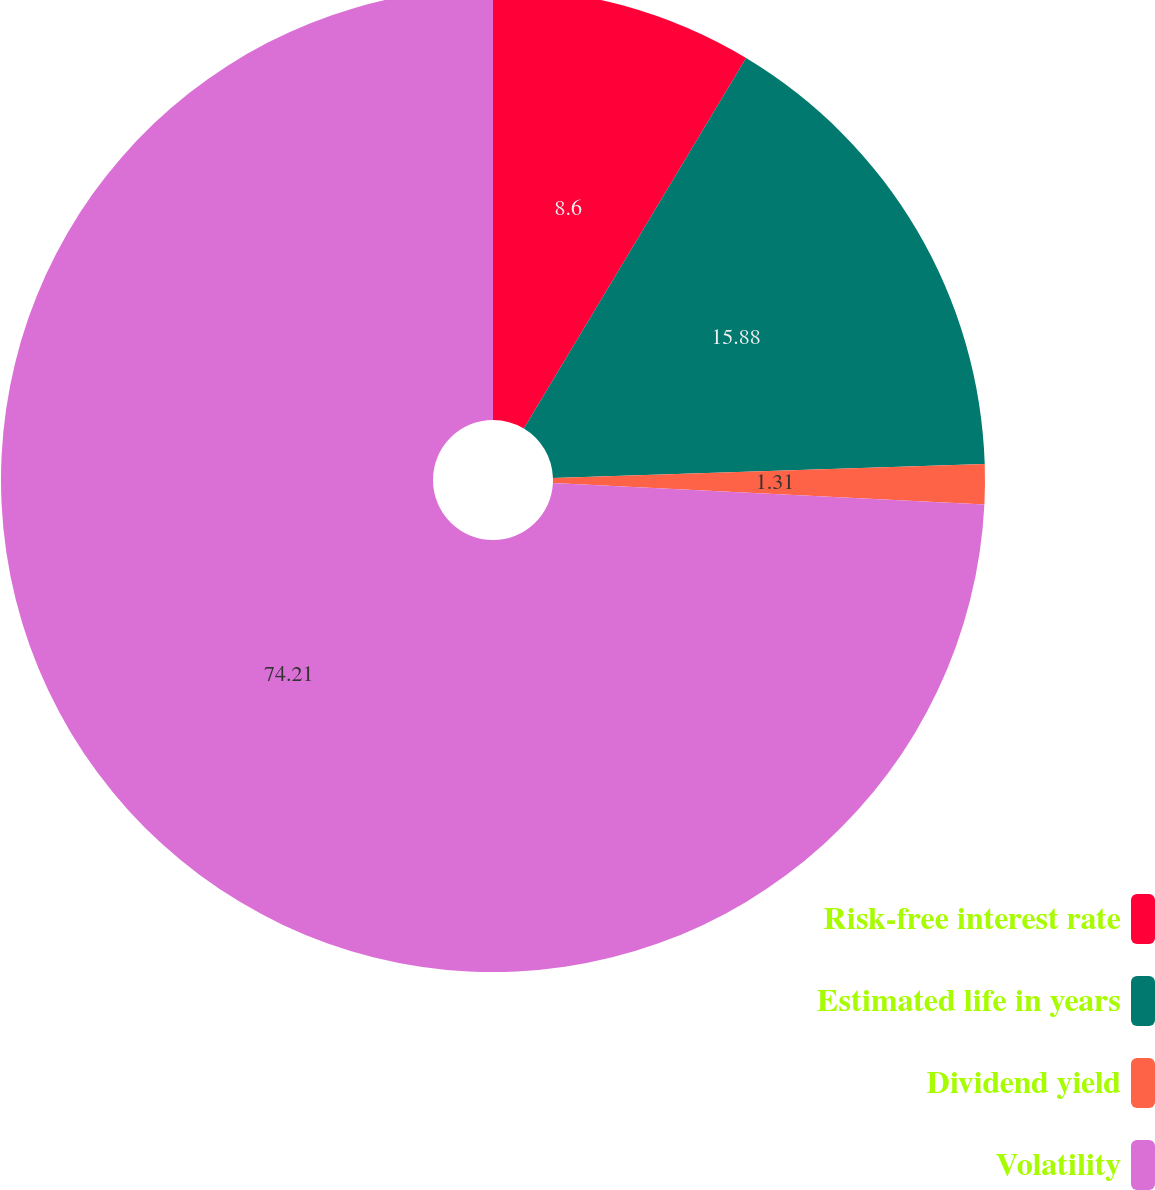Convert chart. <chart><loc_0><loc_0><loc_500><loc_500><pie_chart><fcel>Risk-free interest rate<fcel>Estimated life in years<fcel>Dividend yield<fcel>Volatility<nl><fcel>8.6%<fcel>15.88%<fcel>1.31%<fcel>74.21%<nl></chart> 